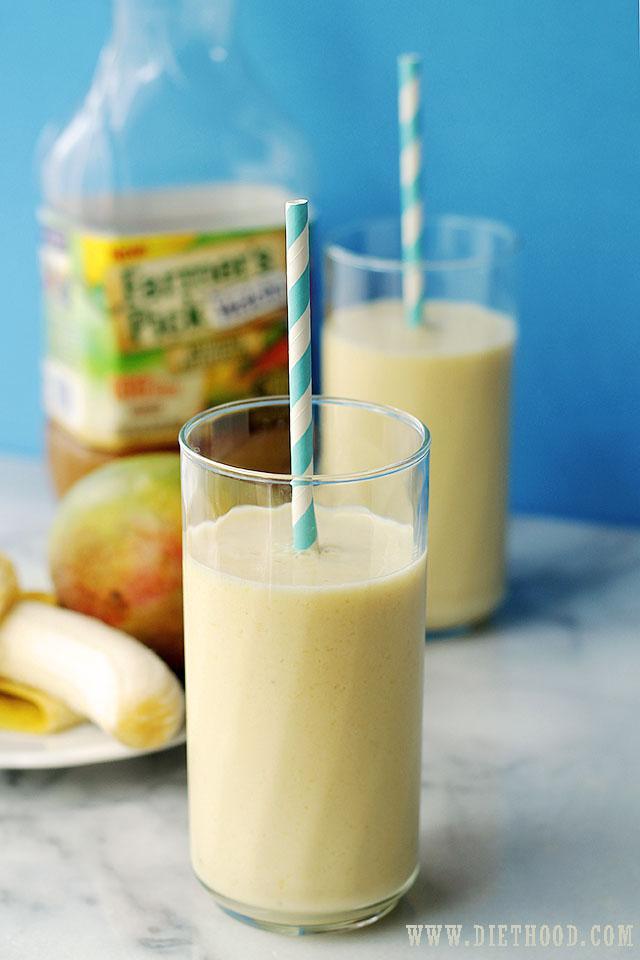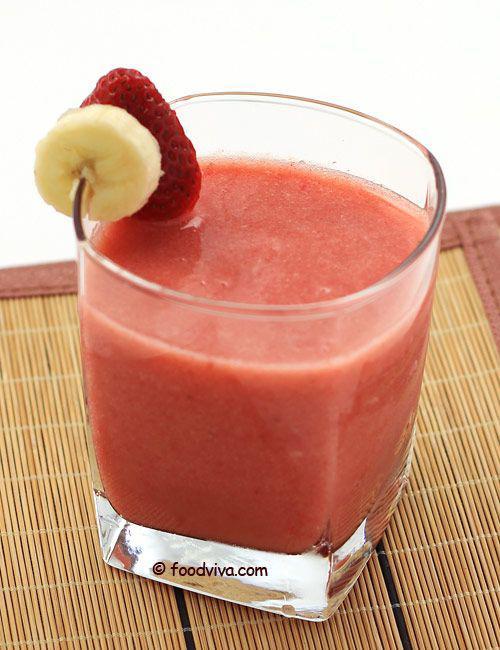The first image is the image on the left, the second image is the image on the right. For the images shown, is this caption "The straws have stripes on them." true? Answer yes or no. Yes. The first image is the image on the left, the second image is the image on the right. Evaluate the accuracy of this statement regarding the images: "The image on the left shows two smoothie glasses next to at least one banana.". Is it true? Answer yes or no. Yes. 